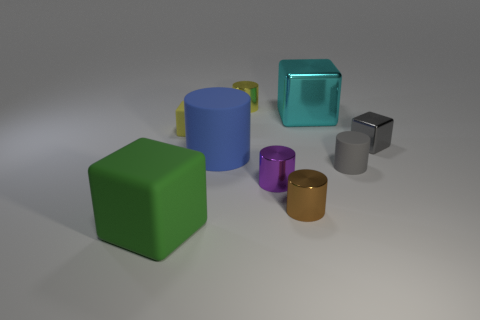Subtract all small gray cylinders. How many cylinders are left? 4 Subtract all cubes. How many objects are left? 5 Subtract all yellow cylinders. How many cylinders are left? 4 Subtract 1 blocks. How many blocks are left? 3 Subtract all blocks. Subtract all gray cylinders. How many objects are left? 4 Add 6 big blocks. How many big blocks are left? 8 Add 6 tiny red rubber cubes. How many tiny red rubber cubes exist? 6 Subtract 0 cyan cylinders. How many objects are left? 9 Subtract all purple cylinders. Subtract all green spheres. How many cylinders are left? 4 